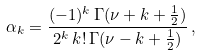Convert formula to latex. <formula><loc_0><loc_0><loc_500><loc_500>\alpha _ { k } = \frac { ( - 1 ) ^ { k } \, \Gamma ( \nu + k + \frac { 1 } { 2 } ) } { 2 ^ { k } \, k ! \, \Gamma ( \nu - k + \frac { 1 } { 2 } ) } \, ,</formula> 